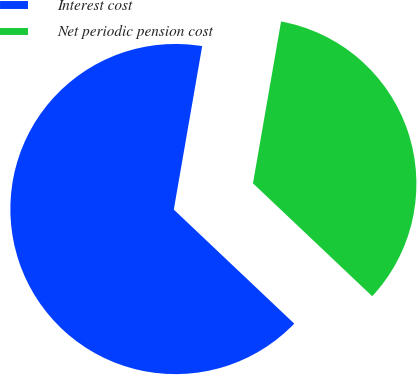Convert chart. <chart><loc_0><loc_0><loc_500><loc_500><pie_chart><fcel>Interest cost<fcel>Net periodic pension cost<nl><fcel>65.67%<fcel>34.33%<nl></chart> 